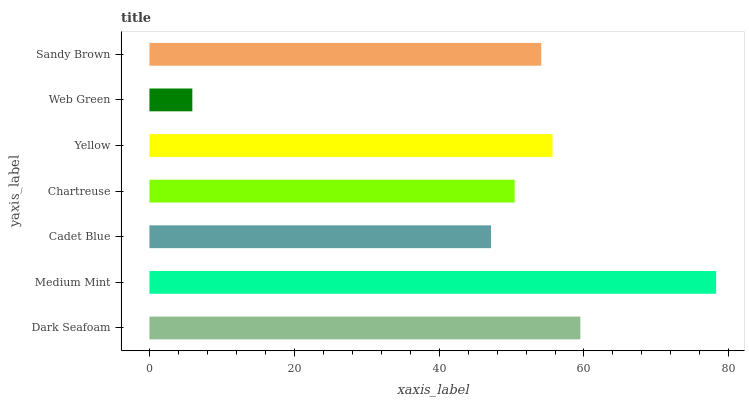Is Web Green the minimum?
Answer yes or no. Yes. Is Medium Mint the maximum?
Answer yes or no. Yes. Is Cadet Blue the minimum?
Answer yes or no. No. Is Cadet Blue the maximum?
Answer yes or no. No. Is Medium Mint greater than Cadet Blue?
Answer yes or no. Yes. Is Cadet Blue less than Medium Mint?
Answer yes or no. Yes. Is Cadet Blue greater than Medium Mint?
Answer yes or no. No. Is Medium Mint less than Cadet Blue?
Answer yes or no. No. Is Sandy Brown the high median?
Answer yes or no. Yes. Is Sandy Brown the low median?
Answer yes or no. Yes. Is Dark Seafoam the high median?
Answer yes or no. No. Is Dark Seafoam the low median?
Answer yes or no. No. 